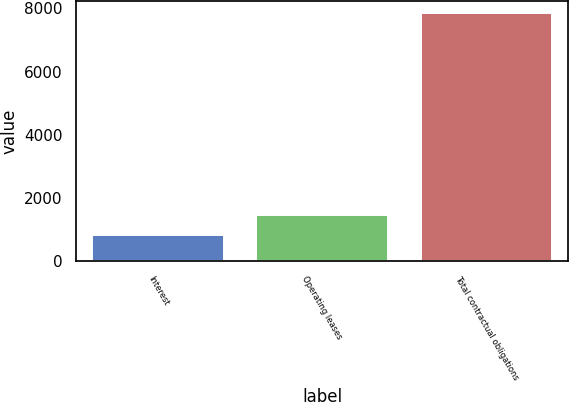Convert chart to OTSL. <chart><loc_0><loc_0><loc_500><loc_500><bar_chart><fcel>Interest<fcel>Operating leases<fcel>Total contractual obligations<nl><fcel>820<fcel>1471.2<fcel>7841.2<nl></chart> 